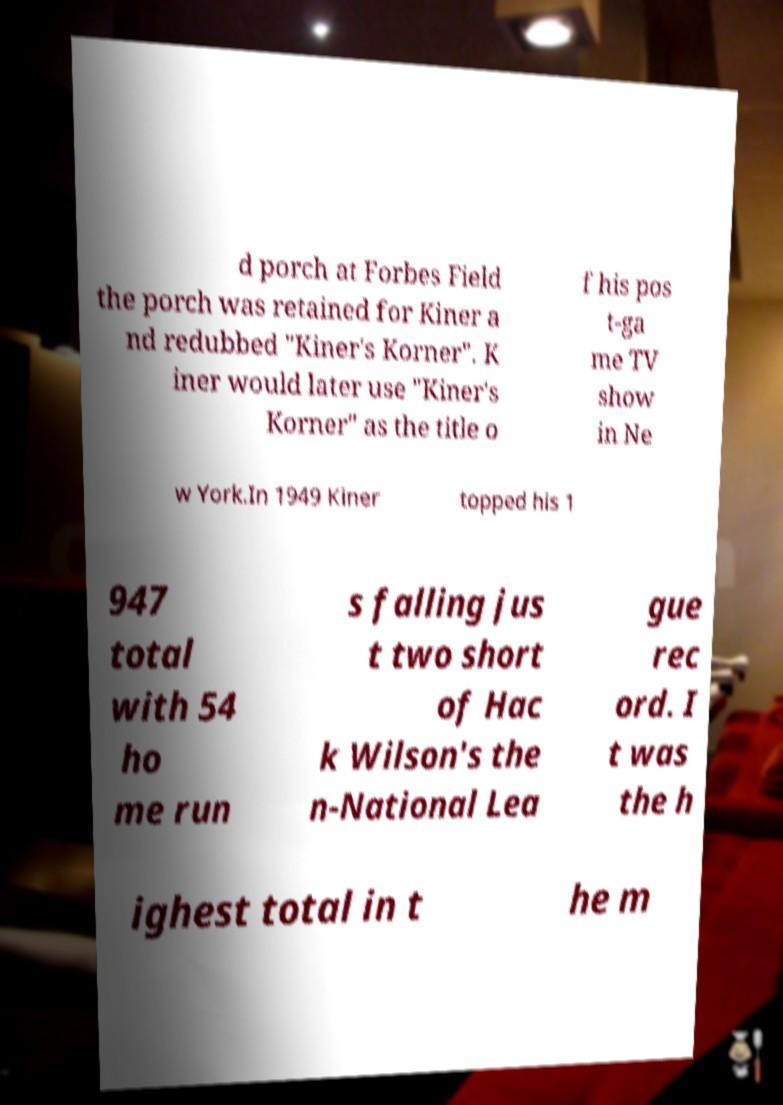Could you assist in decoding the text presented in this image and type it out clearly? d porch at Forbes Field the porch was retained for Kiner a nd redubbed "Kiner's Korner". K iner would later use "Kiner's Korner" as the title o f his pos t-ga me TV show in Ne w York.In 1949 Kiner topped his 1 947 total with 54 ho me run s falling jus t two short of Hac k Wilson's the n-National Lea gue rec ord. I t was the h ighest total in t he m 